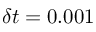<formula> <loc_0><loc_0><loc_500><loc_500>\delta t = 0 . 0 0 1</formula> 